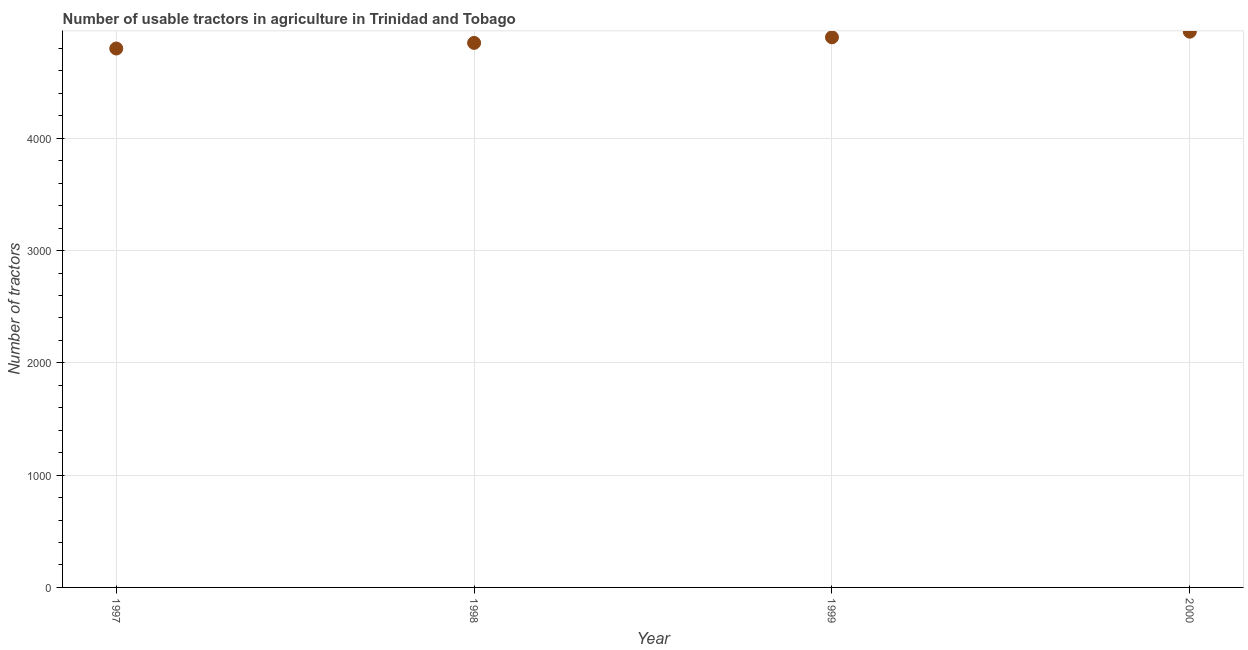What is the number of tractors in 2000?
Offer a terse response. 4950. Across all years, what is the maximum number of tractors?
Your response must be concise. 4950. Across all years, what is the minimum number of tractors?
Offer a terse response. 4800. In which year was the number of tractors minimum?
Offer a very short reply. 1997. What is the sum of the number of tractors?
Keep it short and to the point. 1.95e+04. What is the difference between the number of tractors in 1998 and 1999?
Your answer should be very brief. -50. What is the average number of tractors per year?
Give a very brief answer. 4875. What is the median number of tractors?
Ensure brevity in your answer.  4875. In how many years, is the number of tractors greater than 2600 ?
Give a very brief answer. 4. Do a majority of the years between 1999 and 2000 (inclusive) have number of tractors greater than 1800 ?
Ensure brevity in your answer.  Yes. What is the ratio of the number of tractors in 1997 to that in 2000?
Your answer should be compact. 0.97. Is the number of tractors in 1997 less than that in 1998?
Your answer should be compact. Yes. Is the sum of the number of tractors in 1998 and 2000 greater than the maximum number of tractors across all years?
Provide a succinct answer. Yes. What is the difference between the highest and the lowest number of tractors?
Offer a very short reply. 150. In how many years, is the number of tractors greater than the average number of tractors taken over all years?
Your answer should be very brief. 2. What is the difference between two consecutive major ticks on the Y-axis?
Ensure brevity in your answer.  1000. Does the graph contain grids?
Your answer should be very brief. Yes. What is the title of the graph?
Offer a very short reply. Number of usable tractors in agriculture in Trinidad and Tobago. What is the label or title of the Y-axis?
Offer a very short reply. Number of tractors. What is the Number of tractors in 1997?
Keep it short and to the point. 4800. What is the Number of tractors in 1998?
Keep it short and to the point. 4850. What is the Number of tractors in 1999?
Your answer should be compact. 4900. What is the Number of tractors in 2000?
Offer a very short reply. 4950. What is the difference between the Number of tractors in 1997 and 1999?
Offer a very short reply. -100. What is the difference between the Number of tractors in 1997 and 2000?
Your response must be concise. -150. What is the difference between the Number of tractors in 1998 and 1999?
Make the answer very short. -50. What is the difference between the Number of tractors in 1998 and 2000?
Your response must be concise. -100. What is the ratio of the Number of tractors in 1997 to that in 1998?
Offer a terse response. 0.99. What is the ratio of the Number of tractors in 1997 to that in 1999?
Your response must be concise. 0.98. What is the ratio of the Number of tractors in 1997 to that in 2000?
Your answer should be compact. 0.97. What is the ratio of the Number of tractors in 1998 to that in 1999?
Provide a succinct answer. 0.99. What is the ratio of the Number of tractors in 1999 to that in 2000?
Ensure brevity in your answer.  0.99. 